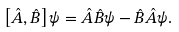Convert formula to latex. <formula><loc_0><loc_0><loc_500><loc_500>\left [ { \hat { A } } , { \hat { B } } \right ] \psi = { \hat { A } } { \hat { B } } \psi - { \hat { B } } { \hat { A } } \psi .</formula> 